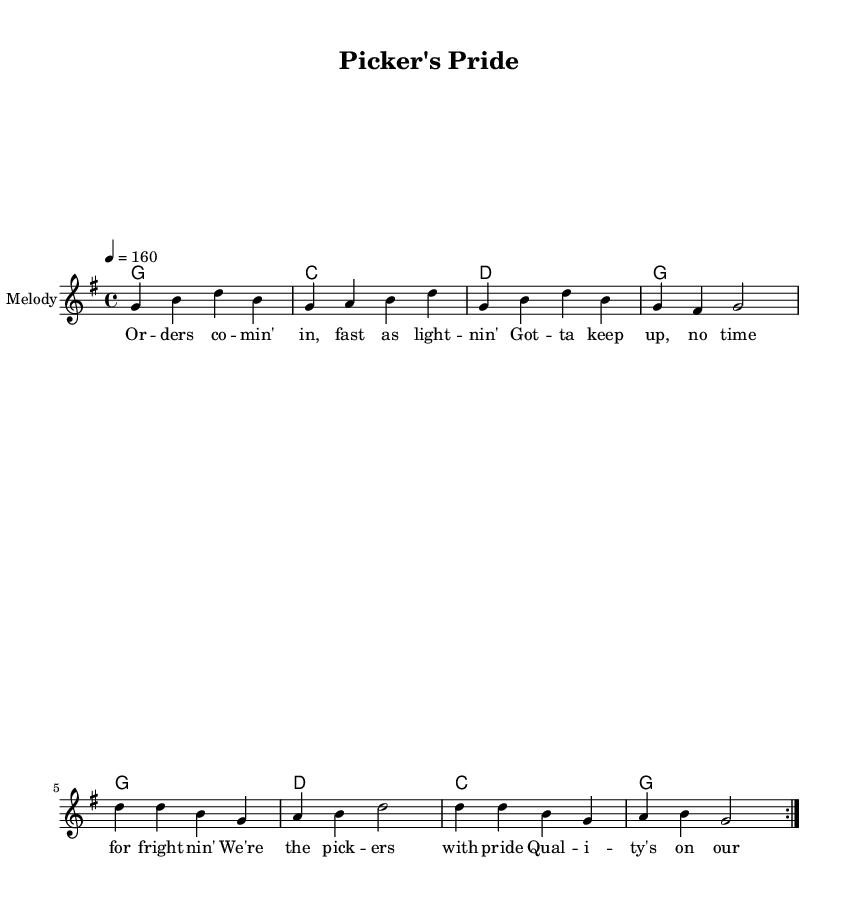What is the key signature of this music? The key signature is G major, which has one sharp (F#) in it, as indicated at the beginning of the staff.
Answer: G major What is the time signature of this music? The time signature is 4/4, which means there are four beats in each measure and the quarter note gets one beat, as shown at the beginning of the sheet music.
Answer: 4/4 What is the tempo marking of this piece? The tempo marking is 160 beats per minute, indicated as "4 = 160" at the beginning of the score, which guides the pace of the music.
Answer: 160 How many measures does the melody repeat? The melody section contains a repeat indication, specifically noted as "volta 2," implying that it should be played twice.
Answer: 2 What is the primary theme of the lyrics in this piece? The lyrics discuss themes of speed, efficiency, and pride in quality during order fulfillment, which directly relates to the fast-paced working environment described in the title.
Answer: Order fulfillment What is the dominant chord in the harmony section? The dominant chord in the harmony is D major, which is the fifth chord of the G major scale and is represented in the chord progression provided in the music.
Answer: D What musical genre does this piece represent? This piece is a country rock song, evident from the upbeat tempo, lyrical content focusing on a fast-paced environment, and the structure typical of the genre.
Answer: Country rock 